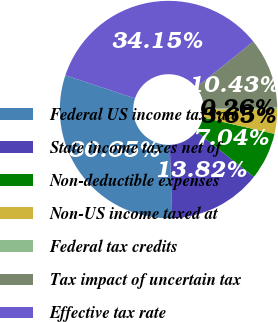Convert chart to OTSL. <chart><loc_0><loc_0><loc_500><loc_500><pie_chart><fcel>Federal US income tax rate<fcel>State income taxes net of<fcel>Non-deductible expenses<fcel>Non-US income taxed at<fcel>Federal tax credits<fcel>Tax impact of uncertain tax<fcel>Effective tax rate<nl><fcel>30.65%<fcel>13.82%<fcel>7.04%<fcel>3.65%<fcel>0.26%<fcel>10.43%<fcel>34.15%<nl></chart> 